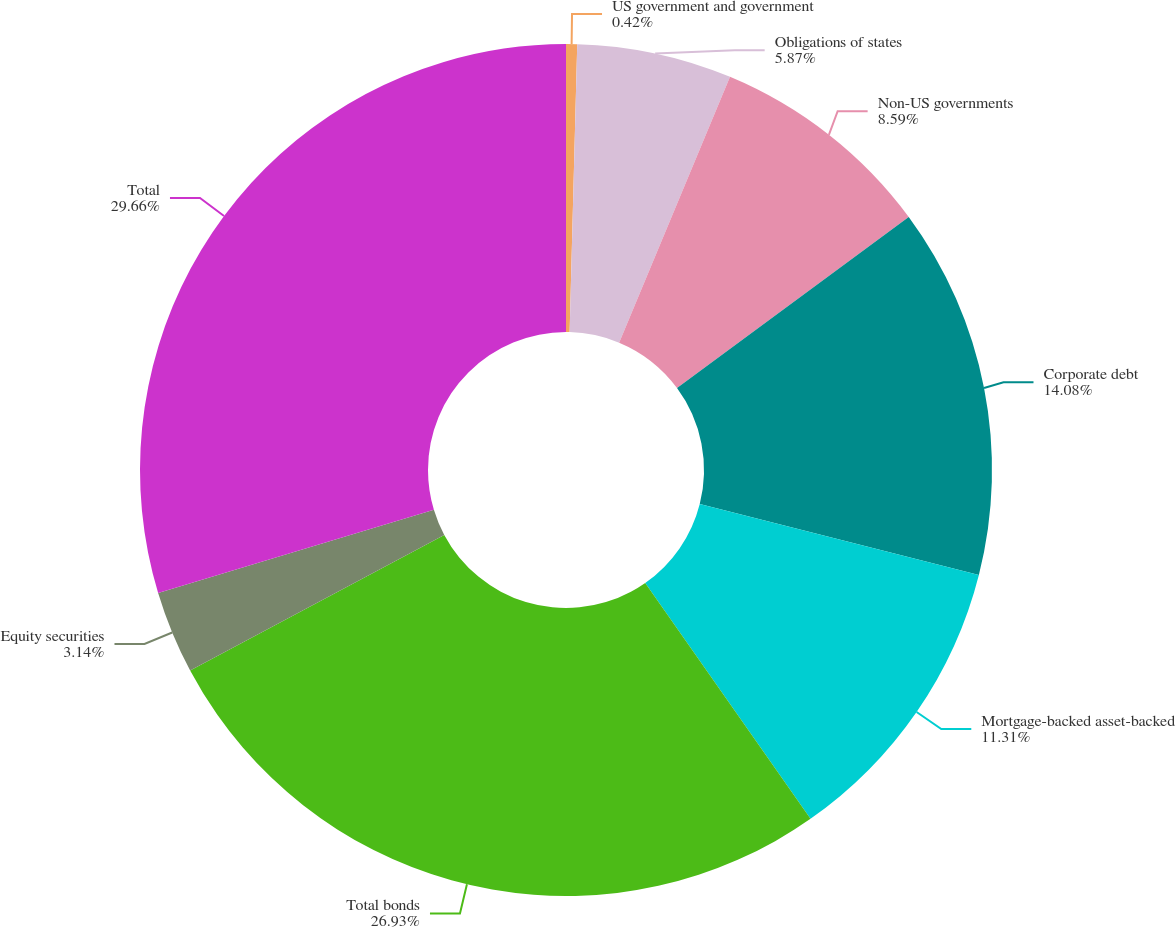Convert chart to OTSL. <chart><loc_0><loc_0><loc_500><loc_500><pie_chart><fcel>US government and government<fcel>Obligations of states<fcel>Non-US governments<fcel>Corporate debt<fcel>Mortgage-backed asset-backed<fcel>Total bonds<fcel>Equity securities<fcel>Total<nl><fcel>0.42%<fcel>5.87%<fcel>8.59%<fcel>14.08%<fcel>11.31%<fcel>26.93%<fcel>3.14%<fcel>29.66%<nl></chart> 